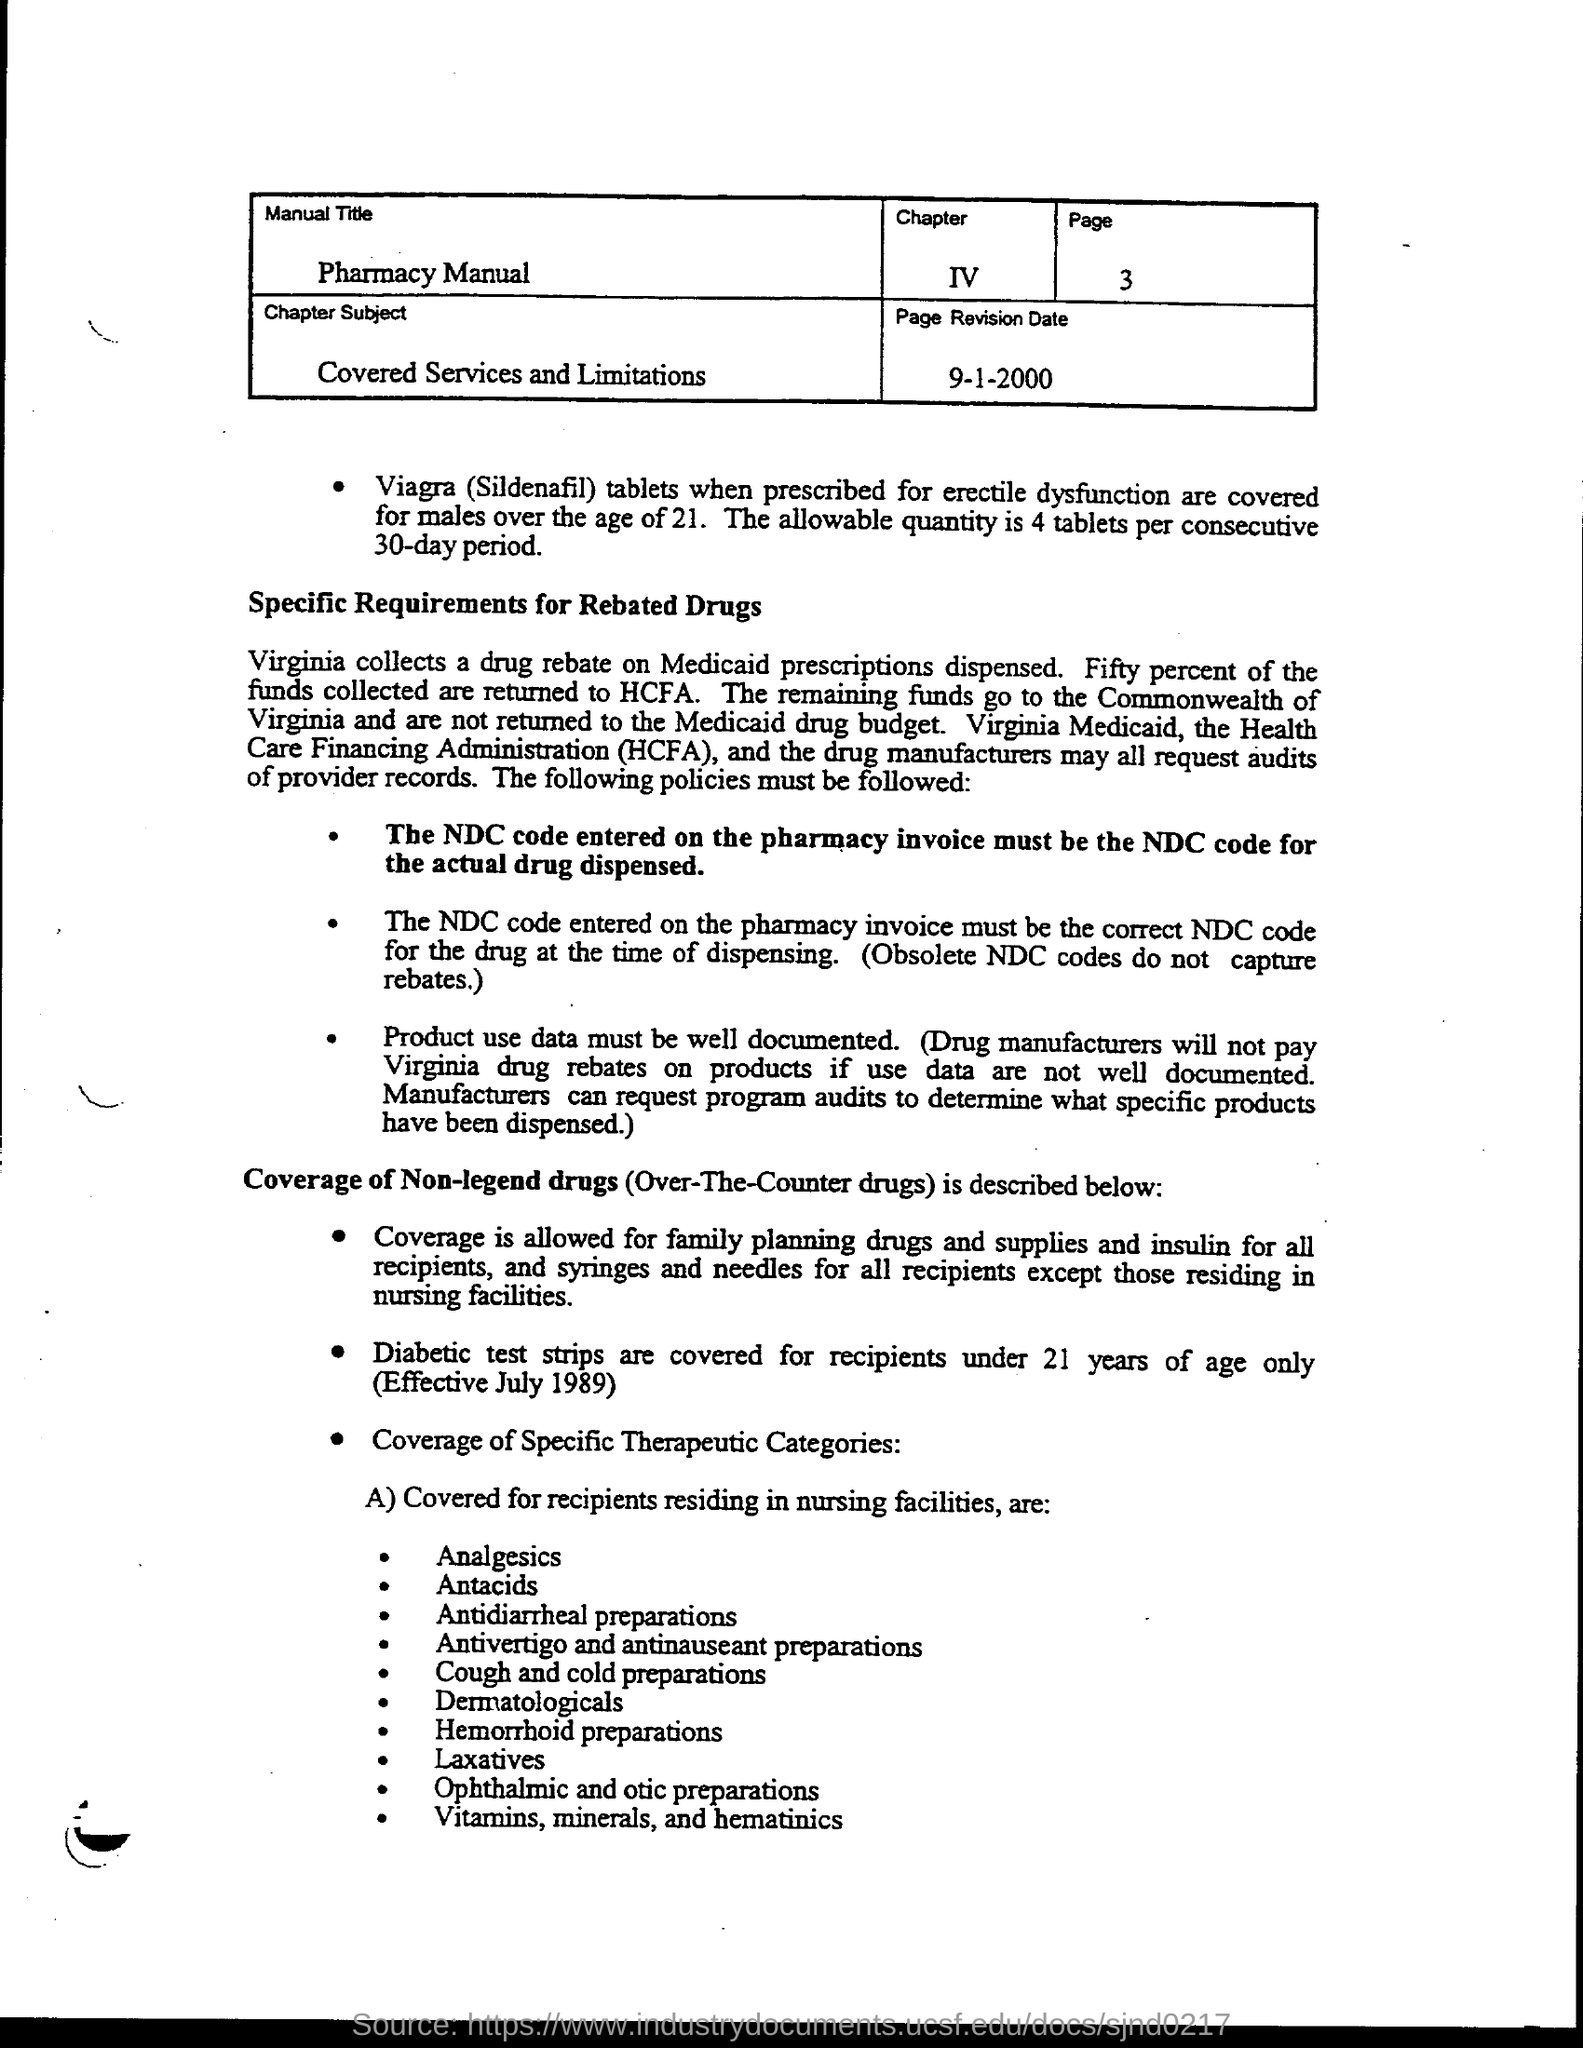Indicate a few pertinent items in this graphic. The chapter number is IV. The manual title is "Pharmacy Manual. The page number inside the box is 3. The chapter is about the subject of "Covered Services and Limitations. HCFA, which stands for Health Care Financing Administration, is a government agency responsible for administering and regulating health care programs, including Medicare and Medicaid. 